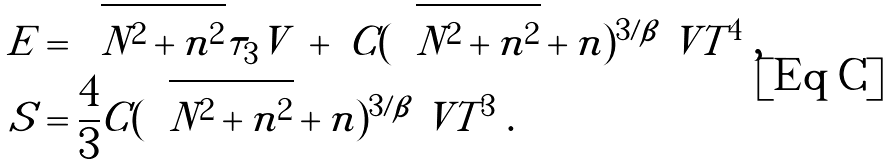Convert formula to latex. <formula><loc_0><loc_0><loc_500><loc_500>E & = \sqrt { N ^ { 2 } + n ^ { 2 } } \tau _ { 3 } V \ + \ C ( \sqrt { N ^ { 2 } + n ^ { 2 } } + n ) ^ { 3 / \beta } \ V T ^ { 4 } \ , \\ S & = \frac { 4 } { 3 } C ( \sqrt { N ^ { 2 } + n ^ { 2 } } + n ) ^ { 3 / \beta } \ V T ^ { 3 } \ .</formula> 